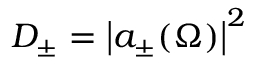<formula> <loc_0><loc_0><loc_500><loc_500>D _ { \pm } = \left | a _ { \pm } ( \Omega ) \right | ^ { 2 }</formula> 